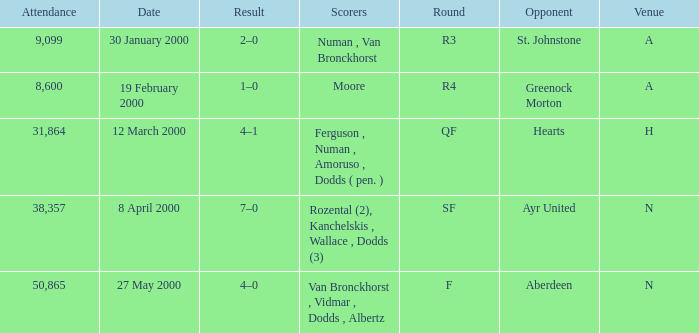Who was on 12 March 2000? Ferguson , Numan , Amoruso , Dodds ( pen. ). 